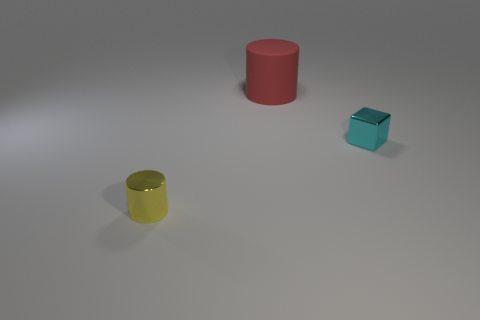Is there anything else that is the same material as the red cylinder?
Keep it short and to the point. No. Are there any other things of the same color as the cube?
Provide a succinct answer. No. There is a object that is both on the left side of the tiny cyan metal block and in front of the large red matte cylinder; what color is it?
Your response must be concise. Yellow. There is a cylinder that is in front of the red matte cylinder; does it have the same size as the big red rubber thing?
Offer a very short reply. No. Is the number of cyan blocks in front of the large red object greater than the number of big metal blocks?
Ensure brevity in your answer.  Yes. Is the shape of the large thing the same as the cyan metallic object?
Offer a very short reply. No. The red object is what size?
Your answer should be very brief. Large. Are there more large cylinders that are behind the tiny cyan shiny cube than large red matte things on the left side of the large red rubber object?
Your answer should be very brief. Yes. Are there any cyan metallic objects in front of the big cylinder?
Give a very brief answer. Yes. Are there any yellow rubber cubes that have the same size as the shiny block?
Your response must be concise. No. 